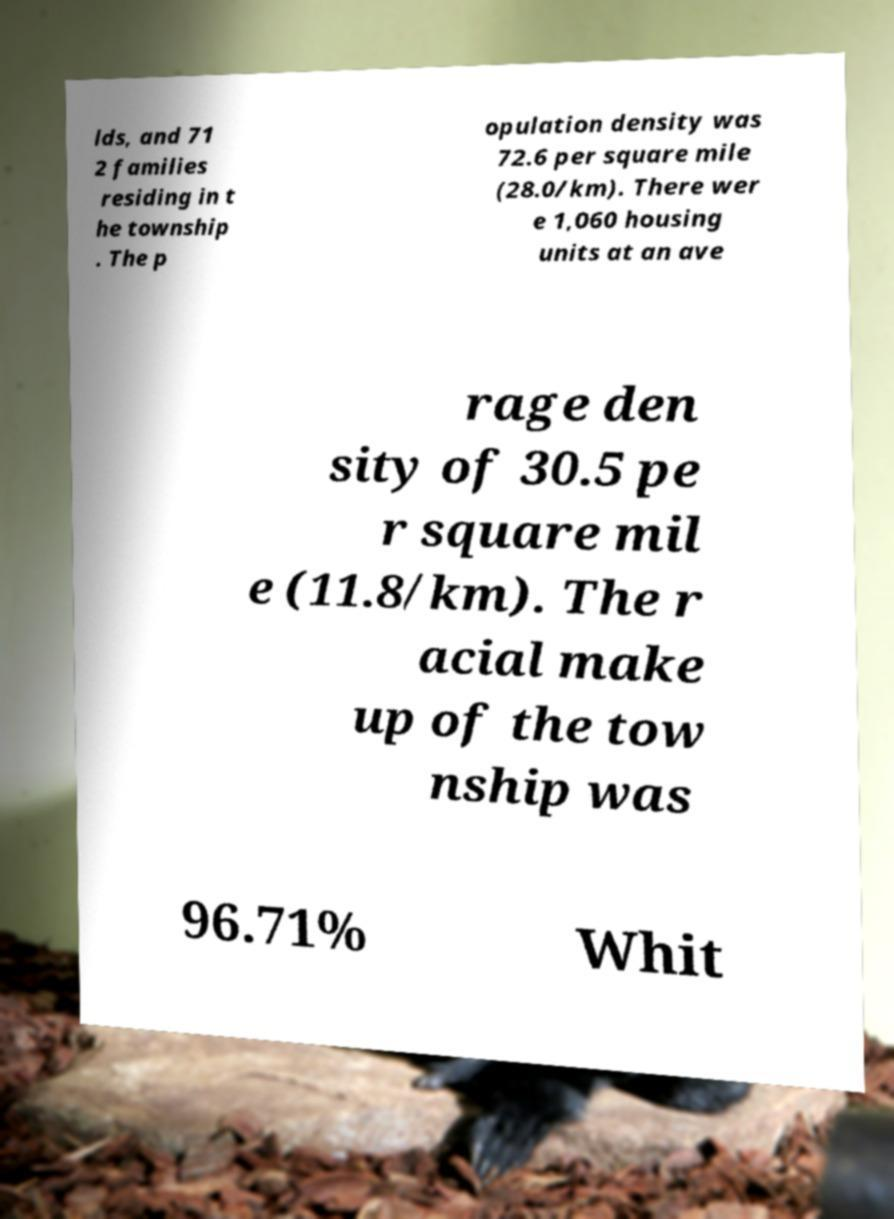Could you assist in decoding the text presented in this image and type it out clearly? lds, and 71 2 families residing in t he township . The p opulation density was 72.6 per square mile (28.0/km). There wer e 1,060 housing units at an ave rage den sity of 30.5 pe r square mil e (11.8/km). The r acial make up of the tow nship was 96.71% Whit 